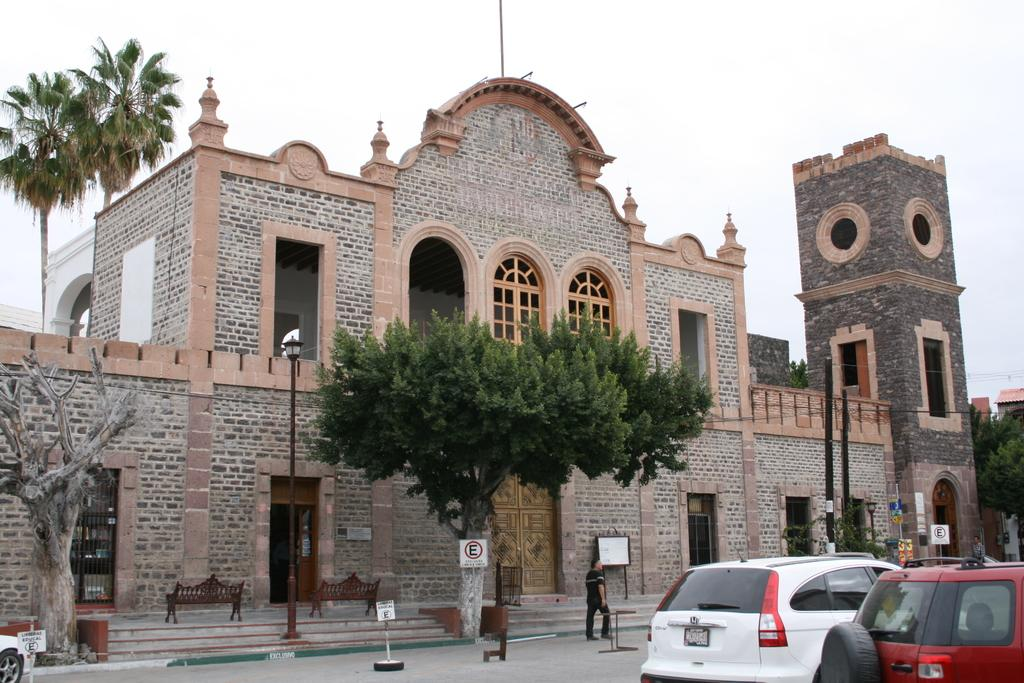What is happening in the foreground of the image? In the foreground, there are vehicles moving on the roads, poles, trees, and sign boards. Can you describe the objects in the foreground? The foreground features vehicles, poles, trees, and sign boards. What can be seen in the background of the image? In the background, there is a building, benches, trees, and the sky. How many types of objects are present in the background? There are four types of objects in the background: a building, benches, trees, and the sky. How many parents are visible in the image? There are no parents visible in the image. What rule is being followed by the vehicles in the image? There is no specific rule visible in the image. How many legs can be seen in the image? There are no legs visible in the image. 